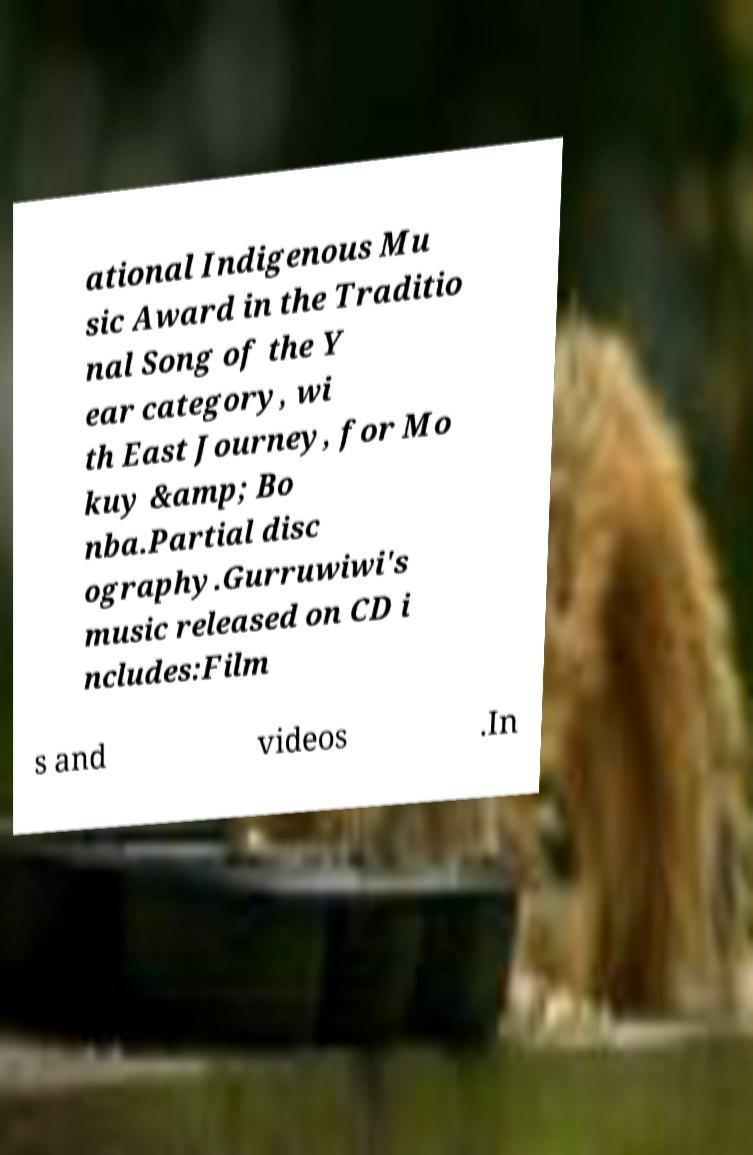Please identify and transcribe the text found in this image. ational Indigenous Mu sic Award in the Traditio nal Song of the Y ear category, wi th East Journey, for Mo kuy &amp; Bo nba.Partial disc ography.Gurruwiwi's music released on CD i ncludes:Film s and videos .In 